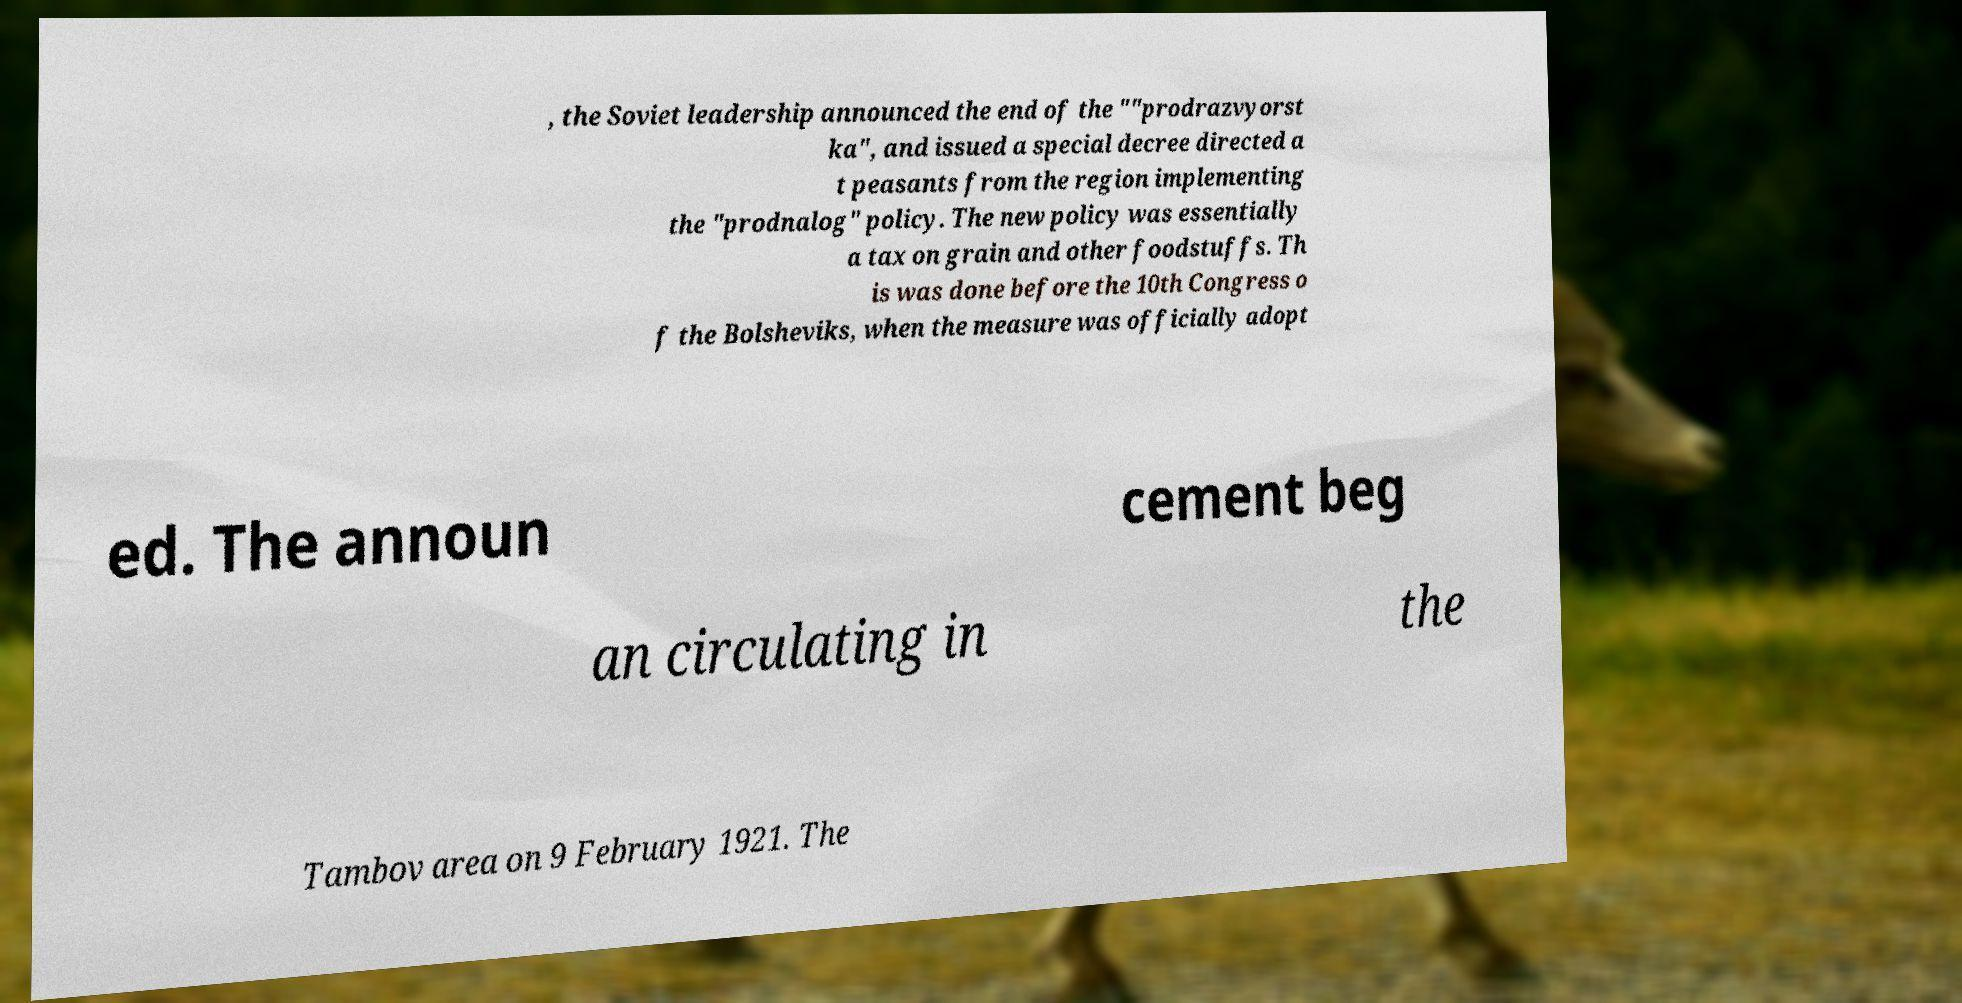Could you extract and type out the text from this image? , the Soviet leadership announced the end of the ""prodrazvyorst ka", and issued a special decree directed a t peasants from the region implementing the "prodnalog" policy. The new policy was essentially a tax on grain and other foodstuffs. Th is was done before the 10th Congress o f the Bolsheviks, when the measure was officially adopt ed. The announ cement beg an circulating in the Tambov area on 9 February 1921. The 